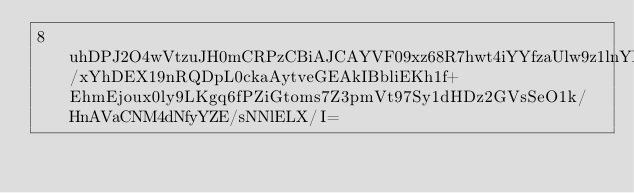<code> <loc_0><loc_0><loc_500><loc_500><_SML_>8uhDPJ2O4wVtzuJH0mCRPzCBiAJCAYVF09xz68R7hwt4iYYfzaUlw9z1lnYPyJKWrtKk0KhisyJPGBRxyZTYDLLLOO/xYhDEX19nRQDpL0ckaAytveGEAkIBbliEKh1f+EhmEjoux0ly9LKgq6fPZiGtoms7Z3pmVt97Sy1dHDz2GVsSeO1k/HnAVaCNM4dNfyYZE/sNNlELX/I=</code> 